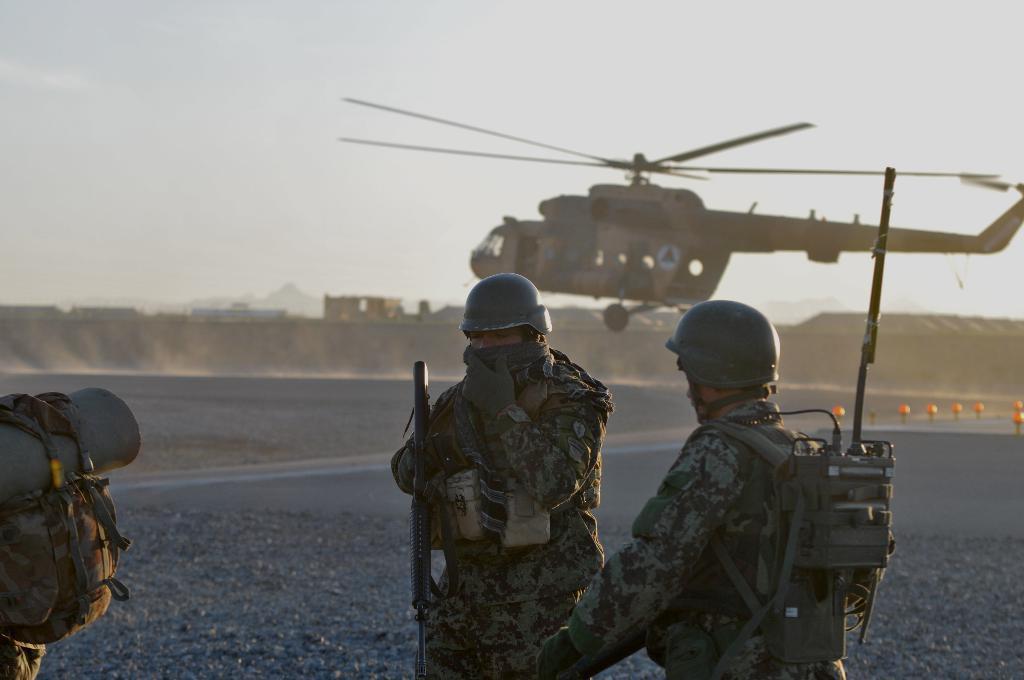How would you summarize this image in a sentence or two? In the image we can see there are people standing and they are wearing uniform. They are wearing helmet and carrying backpack. Behind there is a helicopter and the person is holding a rifle in his hand. 